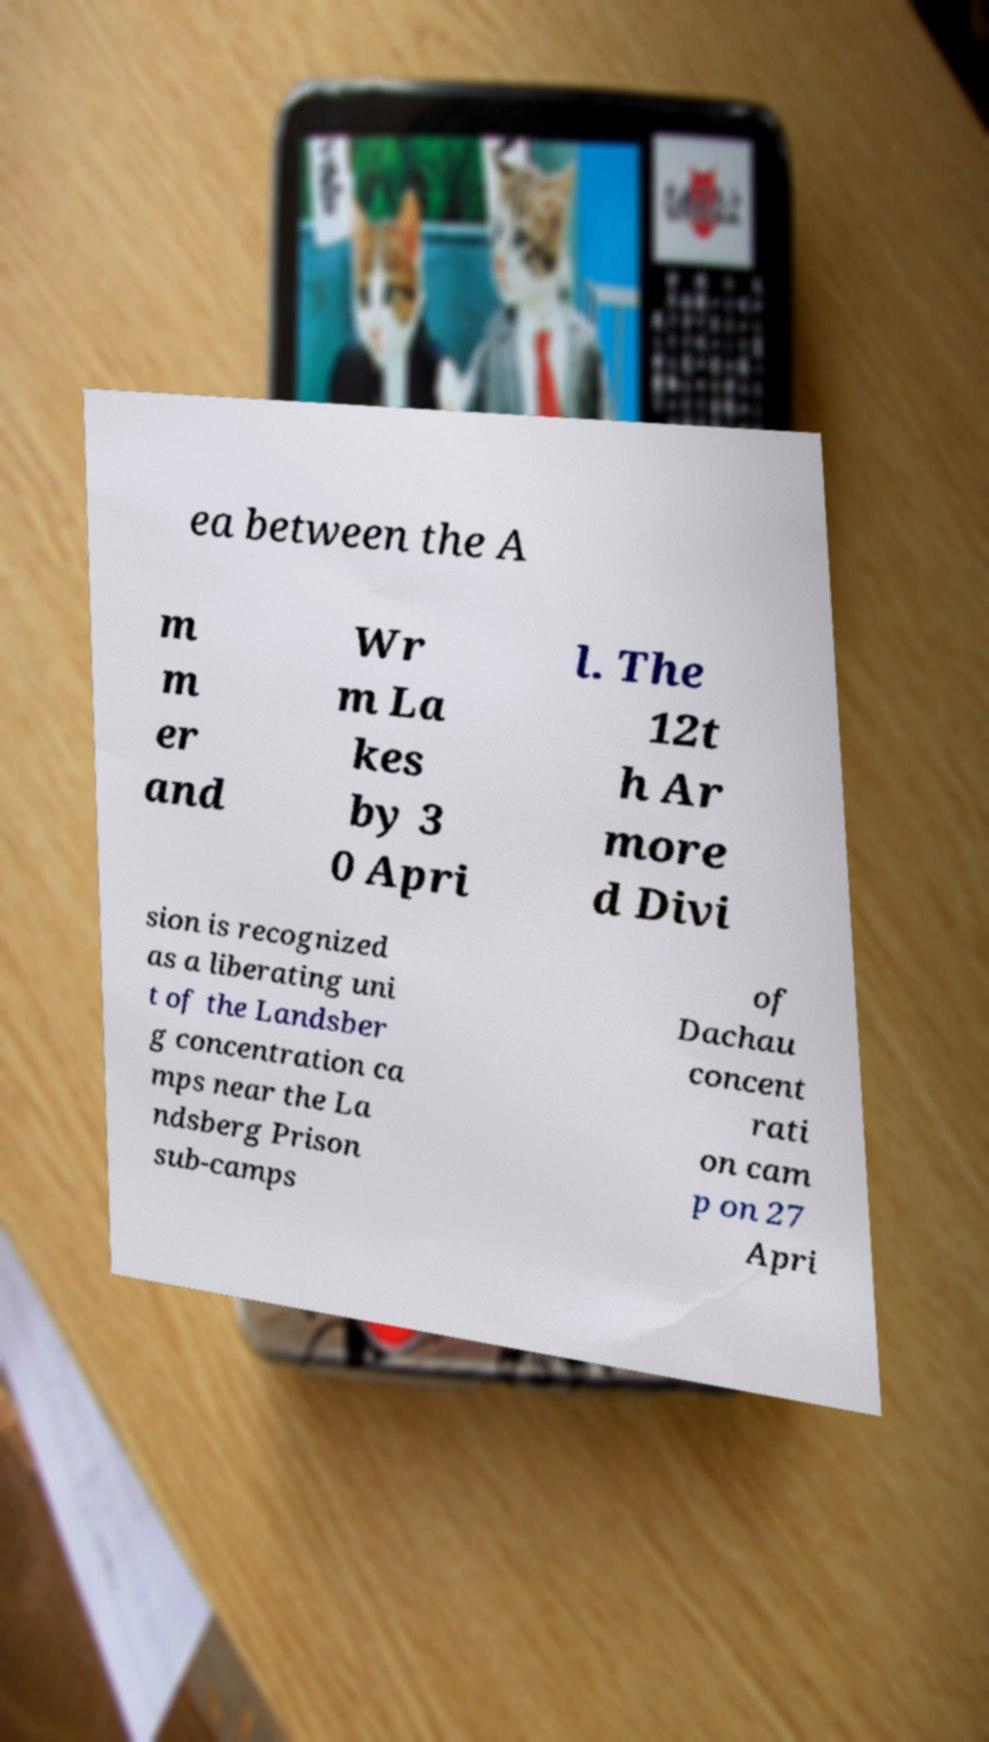Please identify and transcribe the text found in this image. ea between the A m m er and Wr m La kes by 3 0 Apri l. The 12t h Ar more d Divi sion is recognized as a liberating uni t of the Landsber g concentration ca mps near the La ndsberg Prison sub-camps of Dachau concent rati on cam p on 27 Apri 